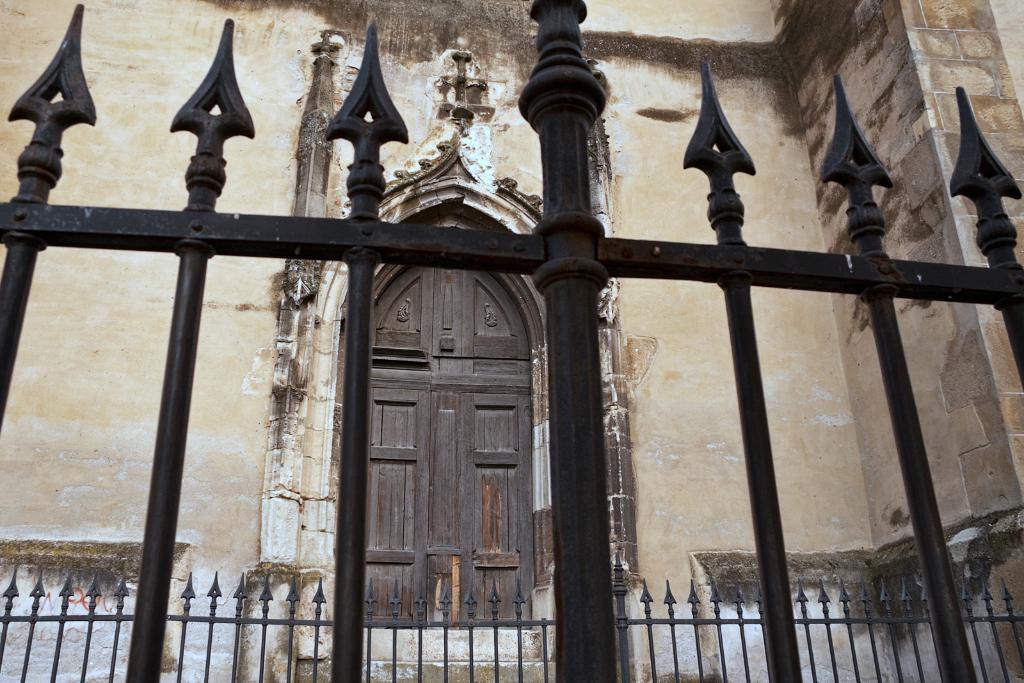Can you describe this image briefly? In this image at front we can see metal fencing. At the back side there is a building. At the center there is a door. 